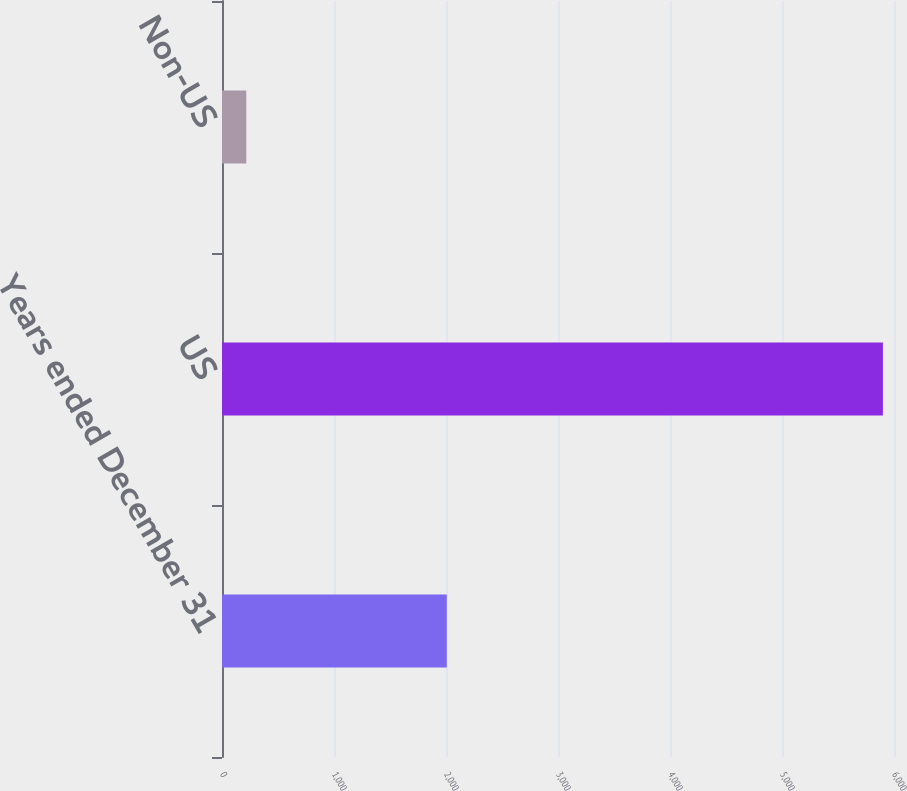<chart> <loc_0><loc_0><loc_500><loc_500><bar_chart><fcel>Years ended December 31<fcel>US<fcel>Non-US<nl><fcel>2007<fcel>5901<fcel>217<nl></chart> 